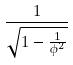<formula> <loc_0><loc_0><loc_500><loc_500>\frac { 1 } { \sqrt { 1 - \frac { 1 } { \phi ^ { 2 } } } }</formula> 